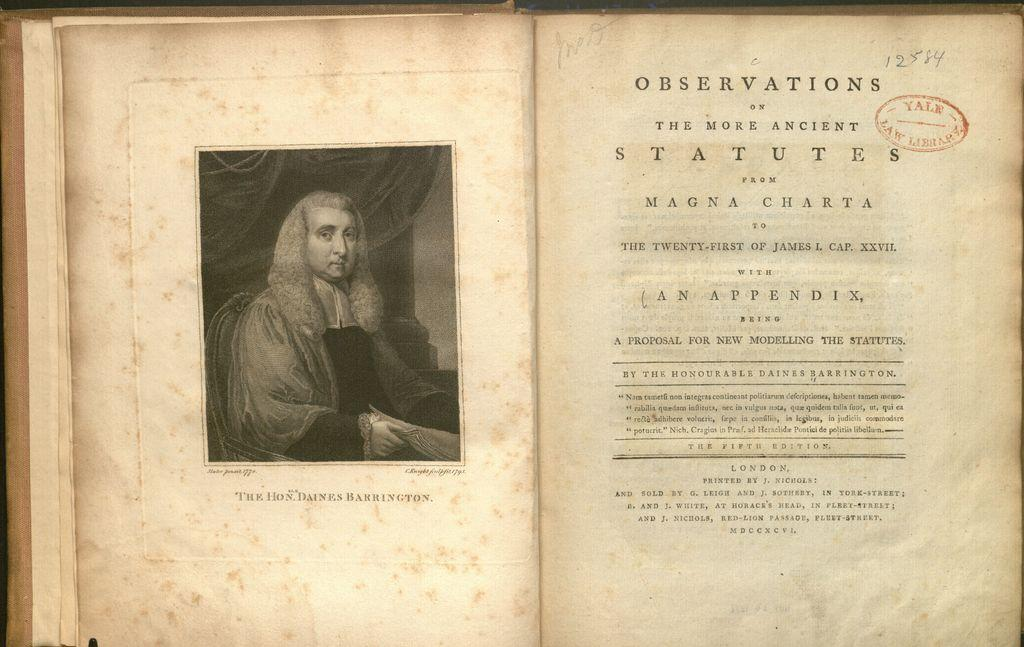Provide a one-sentence caption for the provided image. A page in a book about observations of ancient statutes has been hand-marked as 12584 by someone. 